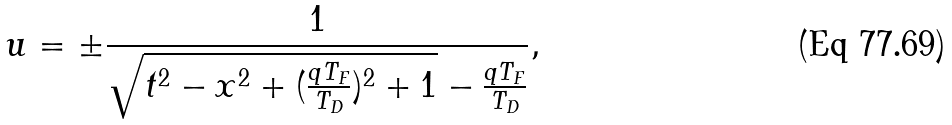Convert formula to latex. <formula><loc_0><loc_0><loc_500><loc_500>u = \pm \frac { 1 } { \sqrt { t ^ { 2 } - x ^ { 2 } + ( \frac { q T _ { F } } { T _ { D } } ) ^ { 2 } + 1 } - \frac { q T _ { F } } { T _ { D } } } ,</formula> 